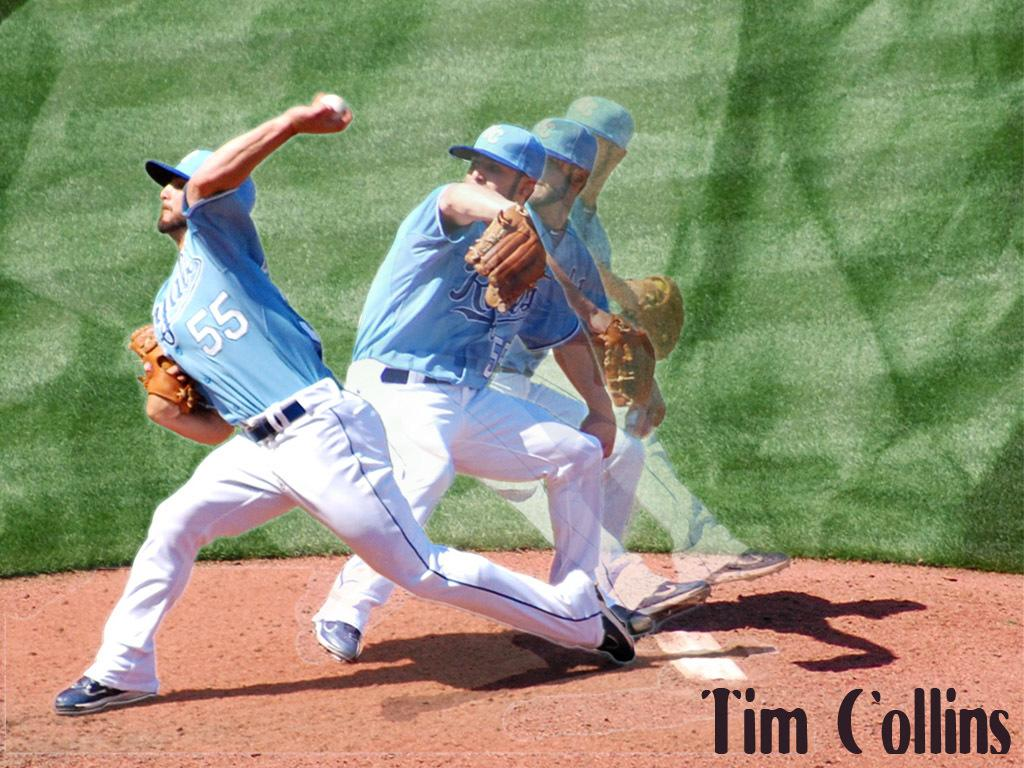<image>
Present a compact description of the photo's key features. Pitcher tim collins from the royals in a light blue jersey 